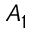Convert formula to latex. <formula><loc_0><loc_0><loc_500><loc_500>A _ { 1 }</formula> 